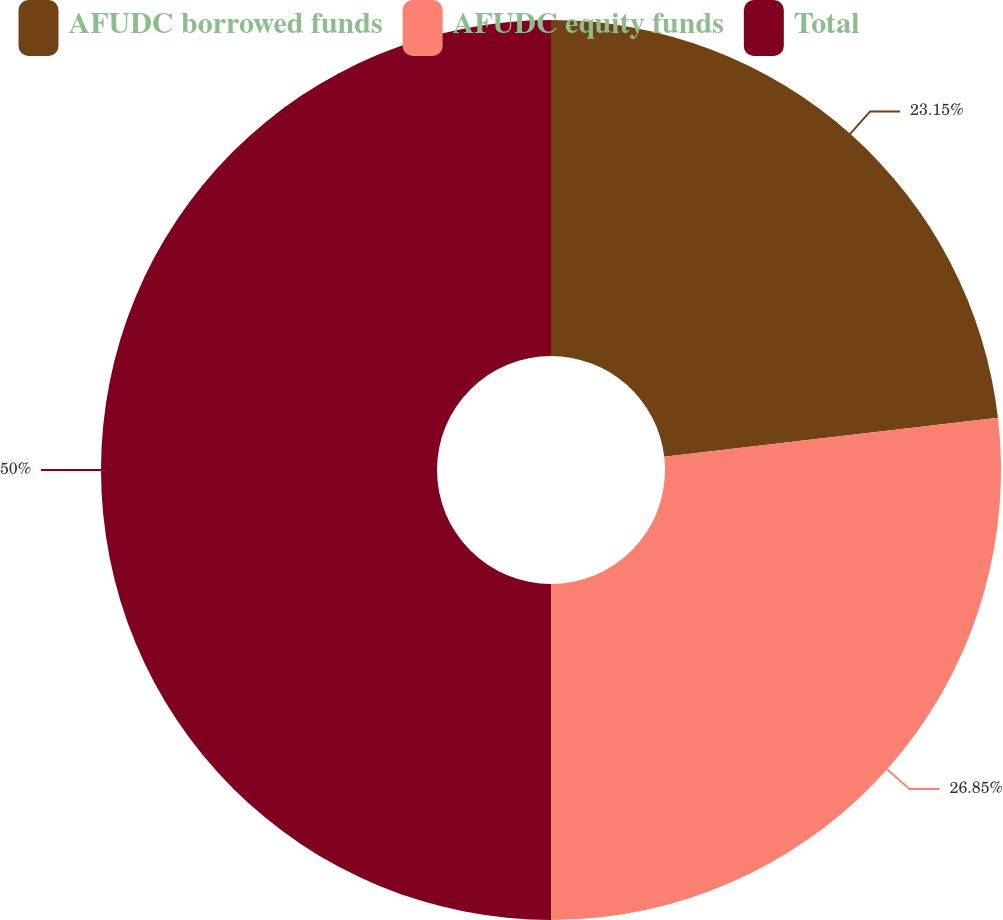Convert chart to OTSL. <chart><loc_0><loc_0><loc_500><loc_500><pie_chart><fcel>AFUDC borrowed funds<fcel>AFUDC equity funds<fcel>Total<nl><fcel>23.15%<fcel>26.85%<fcel>50.0%<nl></chart> 